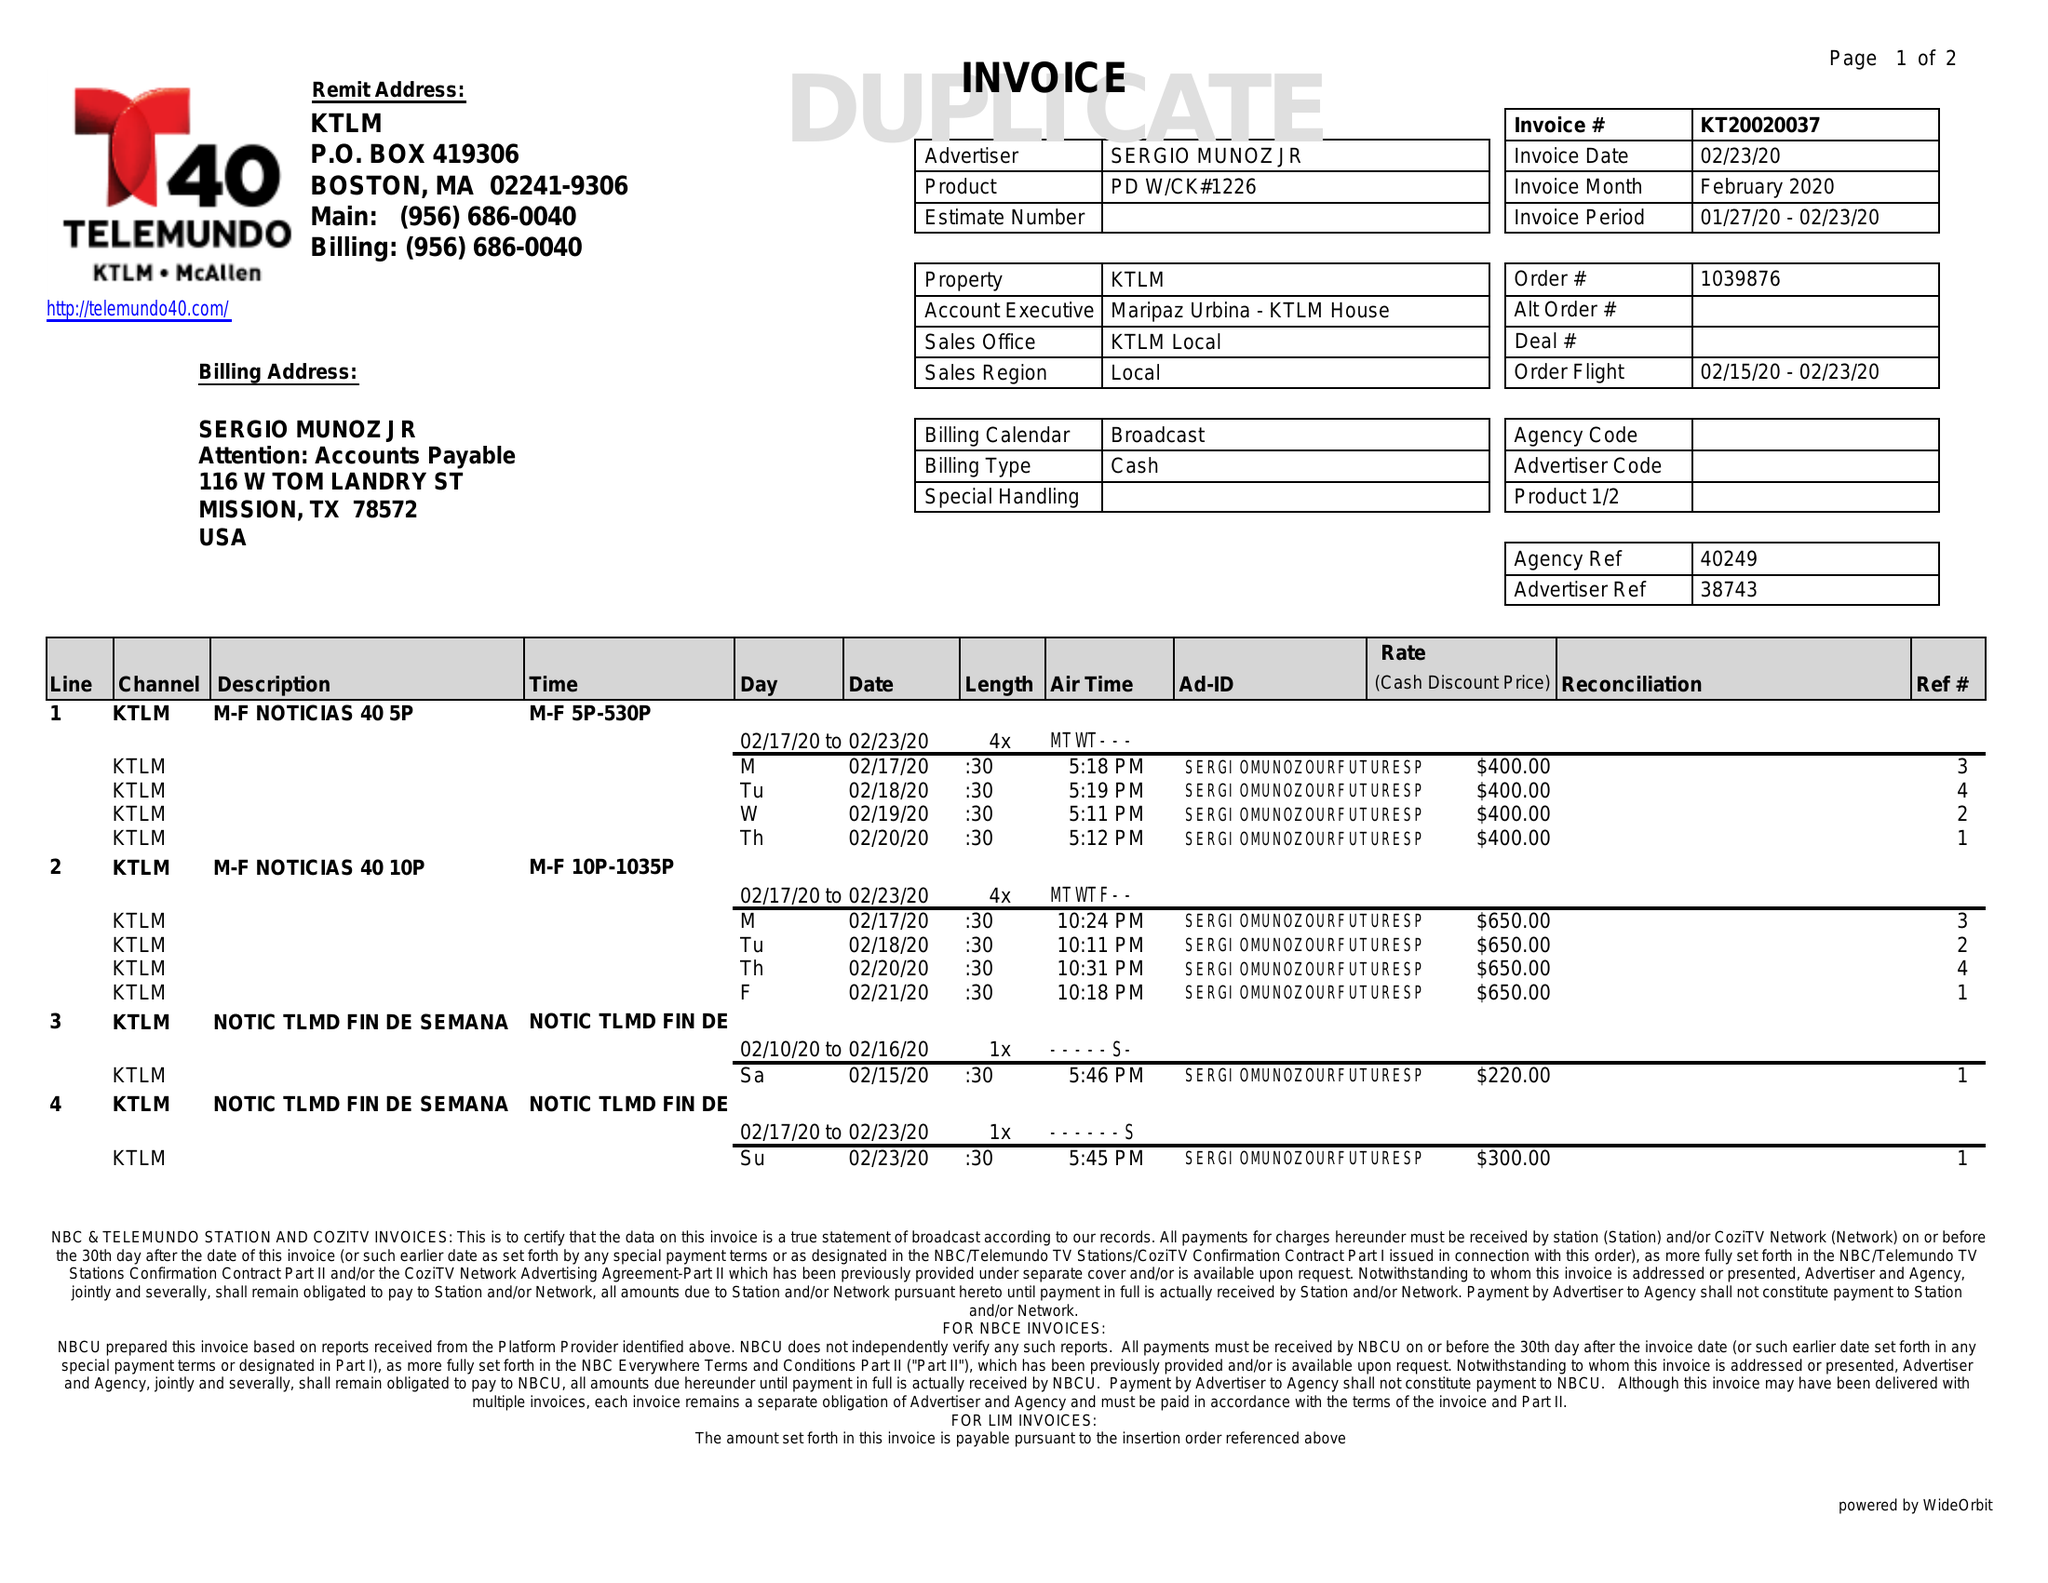What is the value for the gross_amount?
Answer the question using a single word or phrase. 4720.00 